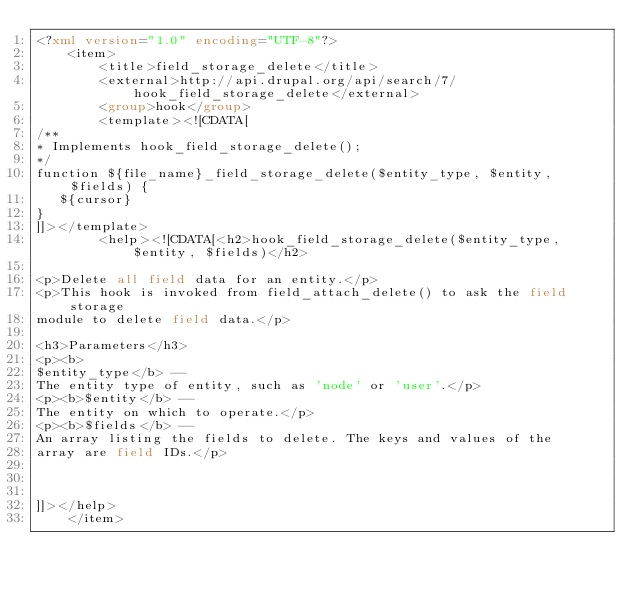<code> <loc_0><loc_0><loc_500><loc_500><_XML_><?xml version="1.0" encoding="UTF-8"?>
	<item>
		<title>field_storage_delete</title>
		<external>http://api.drupal.org/api/search/7/hook_field_storage_delete</external>
		<group>hook</group>
		<template><![CDATA[
/**
* Implements hook_field_storage_delete();
*/
function ${file_name}_field_storage_delete($entity_type, $entity, $fields) {
   ${cursor}
}
]]></template>
		<help><![CDATA[<h2>hook_field_storage_delete($entity_type, $entity, $fields)</h2>

<p>Delete all field data for an entity.</p>
<p>This hook is invoked from field_attach_delete() to ask the field storage
module to delete field data.</p>

<h3>Parameters</h3>
<p><b>
$entity_type</b> -- 
The entity type of entity, such as 'node' or 'user'.</p>
<p><b>$entity</b> -- 
The entity on which to operate.</p>
<p><b>$fields</b> -- 
An array listing the fields to delete. The keys and values of the
array are field IDs.</p>



]]></help>
	</item></code> 